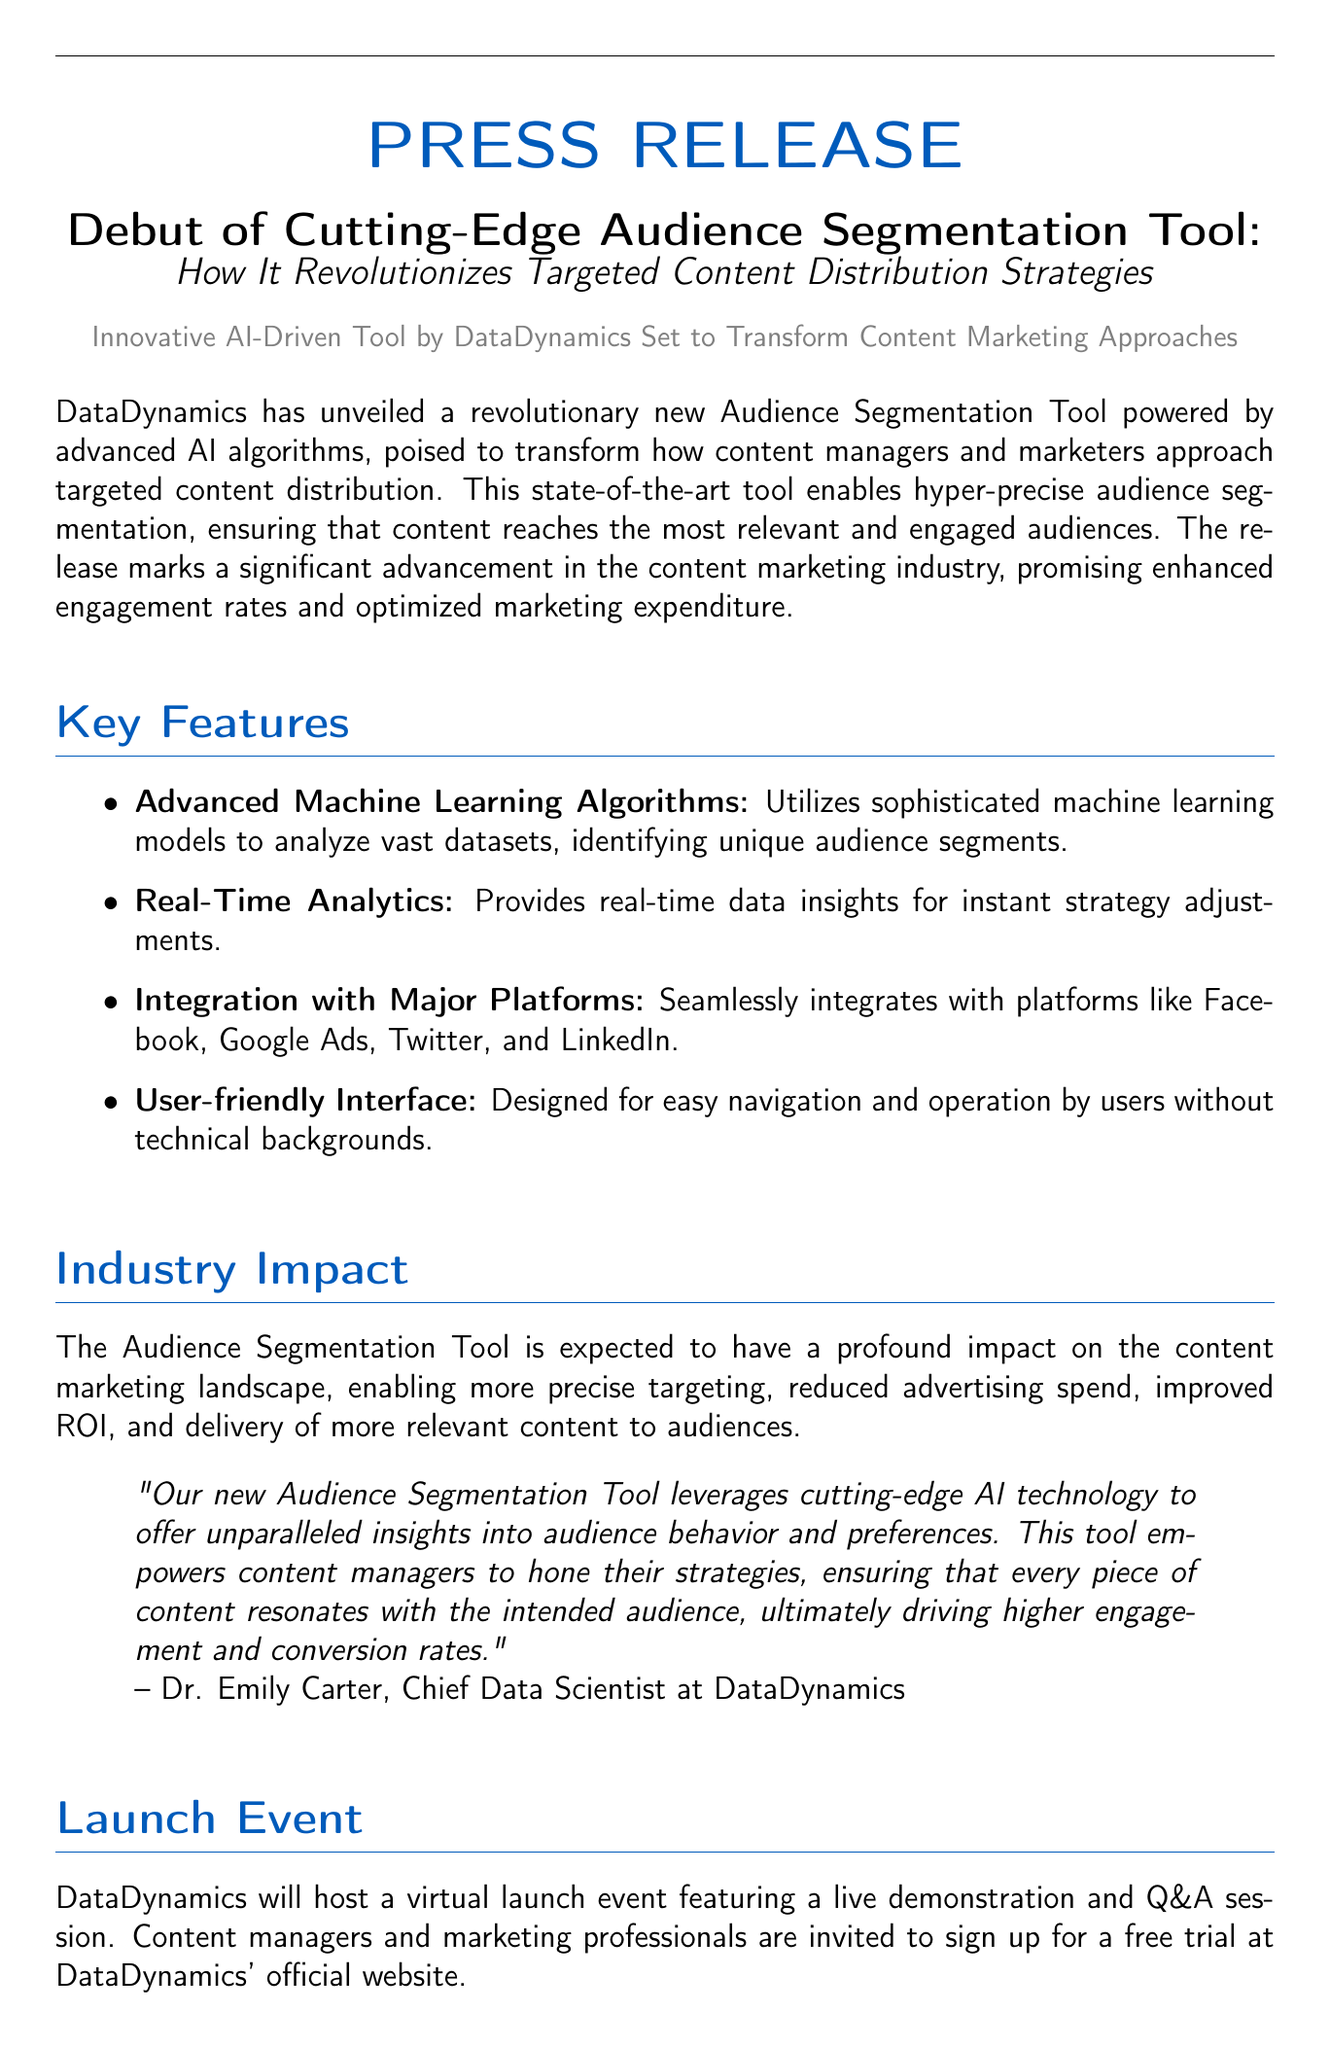What is the name of the new tool? The tool is called the Audience Segmentation Tool.
Answer: Audience Segmentation Tool Who is the Chief Data Scientist at DataDynamics? Dr. Emily Carter is mentioned as the Chief Data Scientist.
Answer: Dr. Emily Carter What type of algorithms does the tool use? The tool utilizes advanced machine learning algorithms.
Answer: advanced machine learning algorithms What is a key feature of the Audience Segmentation Tool related to data? The tool provides real-time data insights.
Answer: real-time data insights What is the expected impact of the tool on advertising spend? The document states that it will reduce advertising spend.
Answer: reduced advertising spend When will the launch event be held? The launch event will be a virtual event, but no specific date is mentioned.
Answer: Virtual launch event What is the address of DataDynamics? The address is 123 Innovation Drive, Suite 456, New York, NY 10001.
Answer: 123 Innovation Drive, Suite 456, New York, NY 10001 Who is invited to the virtual launch event? Content managers and marketing professionals are invited to the event.
Answer: Content managers and marketing professionals How can individuals sign up for a free trial? Individuals can sign up through DataDynamics' official website.
Answer: DataDynamics' official website 